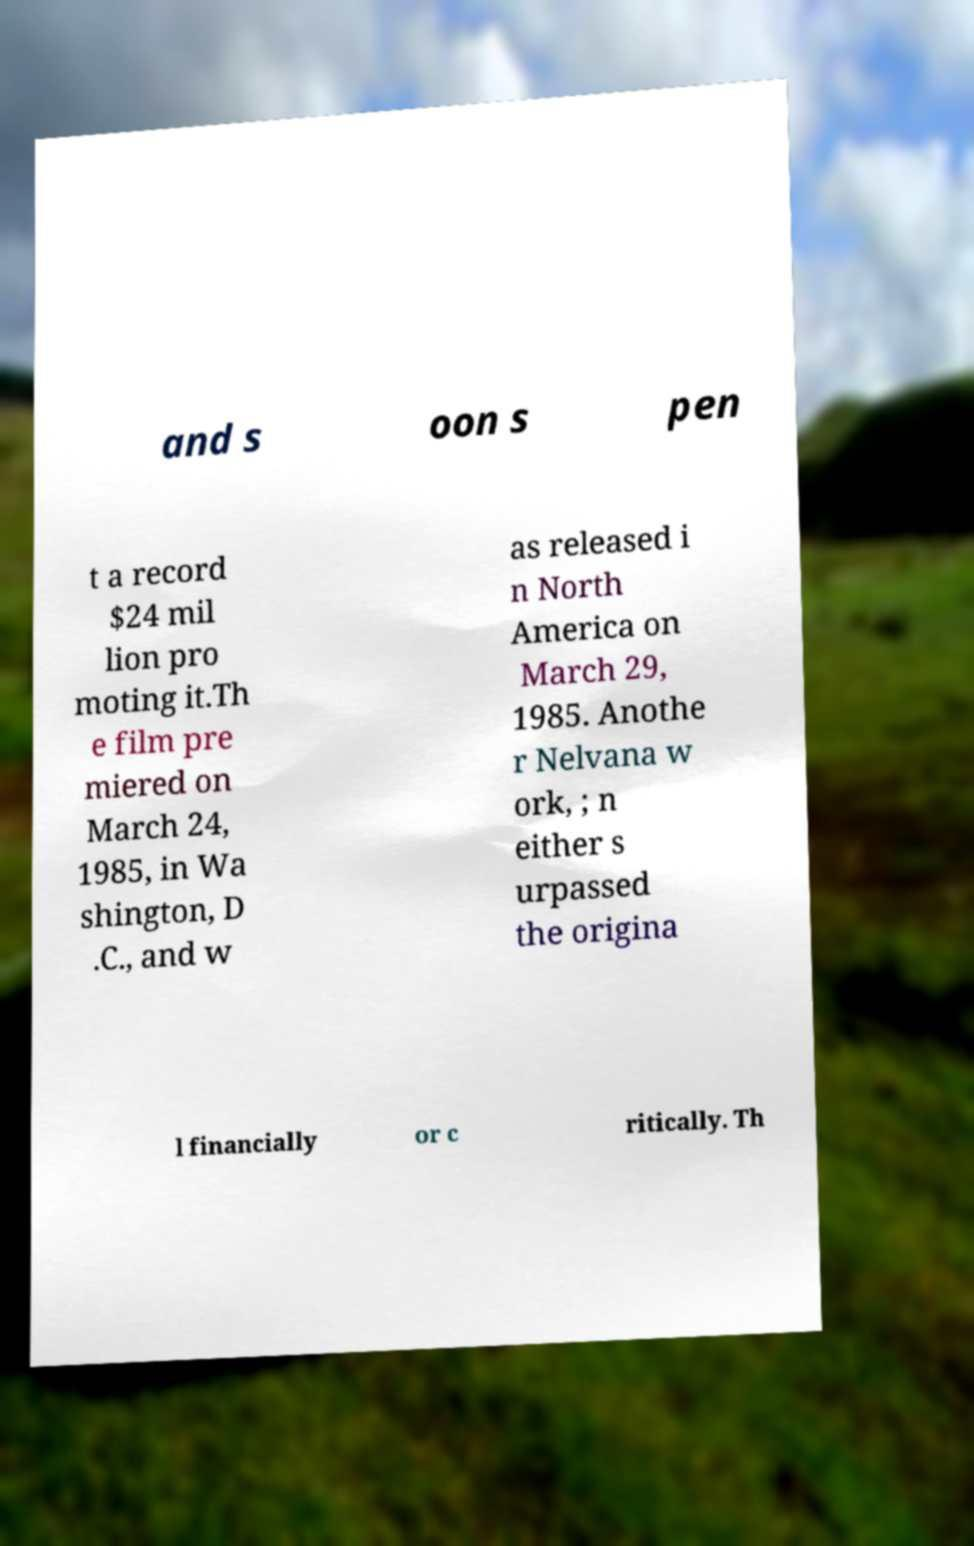Can you accurately transcribe the text from the provided image for me? and s oon s pen t a record $24 mil lion pro moting it.Th e film pre miered on March 24, 1985, in Wa shington, D .C., and w as released i n North America on March 29, 1985. Anothe r Nelvana w ork, ; n either s urpassed the origina l financially or c ritically. Th 